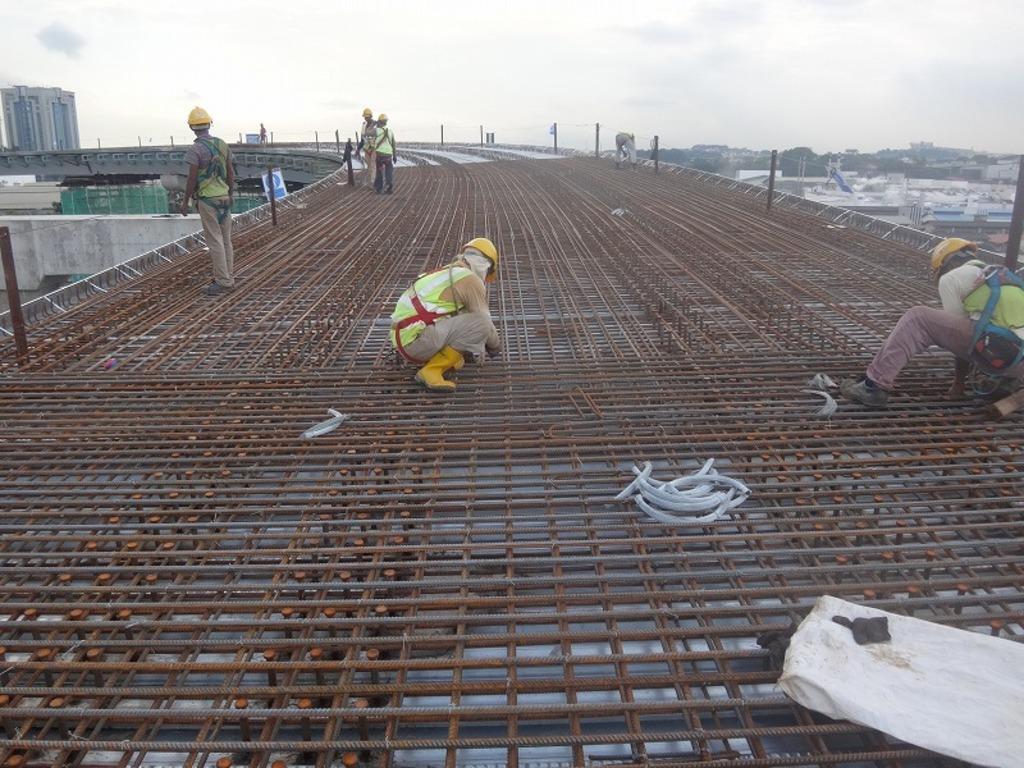Can you describe this image briefly? In this image, in the middle there is a person. On the right there is a person. On the left there are three men. At the bottom there are iron grills, tubes, some other objects. In the middle there is a bridge on that there are people. In the background there are buildings, sky and clouds. 